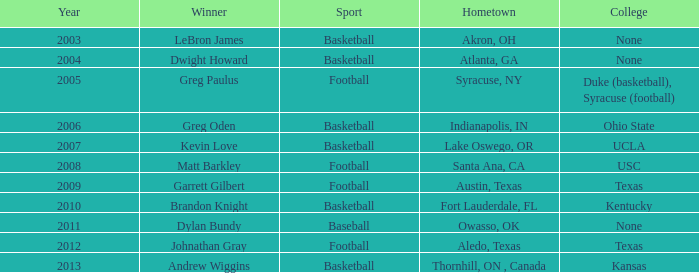What is the total number of Year, when Winner is "Johnathan Gray"? 1.0. 